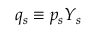<formula> <loc_0><loc_0><loc_500><loc_500>q _ { s } \equiv p _ { s } Y _ { s }</formula> 